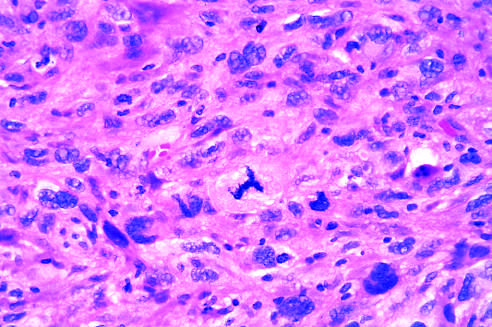what does the prominent cell in the center field have?
Answer the question using a single word or phrase. An abnormal tripolar spindle 